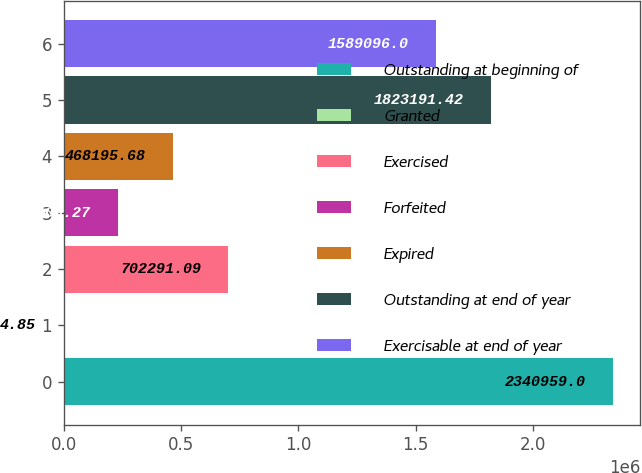Convert chart to OTSL. <chart><loc_0><loc_0><loc_500><loc_500><bar_chart><fcel>Outstanding at beginning of<fcel>Granted<fcel>Exercised<fcel>Forfeited<fcel>Expired<fcel>Outstanding at end of year<fcel>Exercisable at end of year<nl><fcel>2.34096e+06<fcel>4.85<fcel>702291<fcel>234100<fcel>468196<fcel>1.82319e+06<fcel>1.5891e+06<nl></chart> 